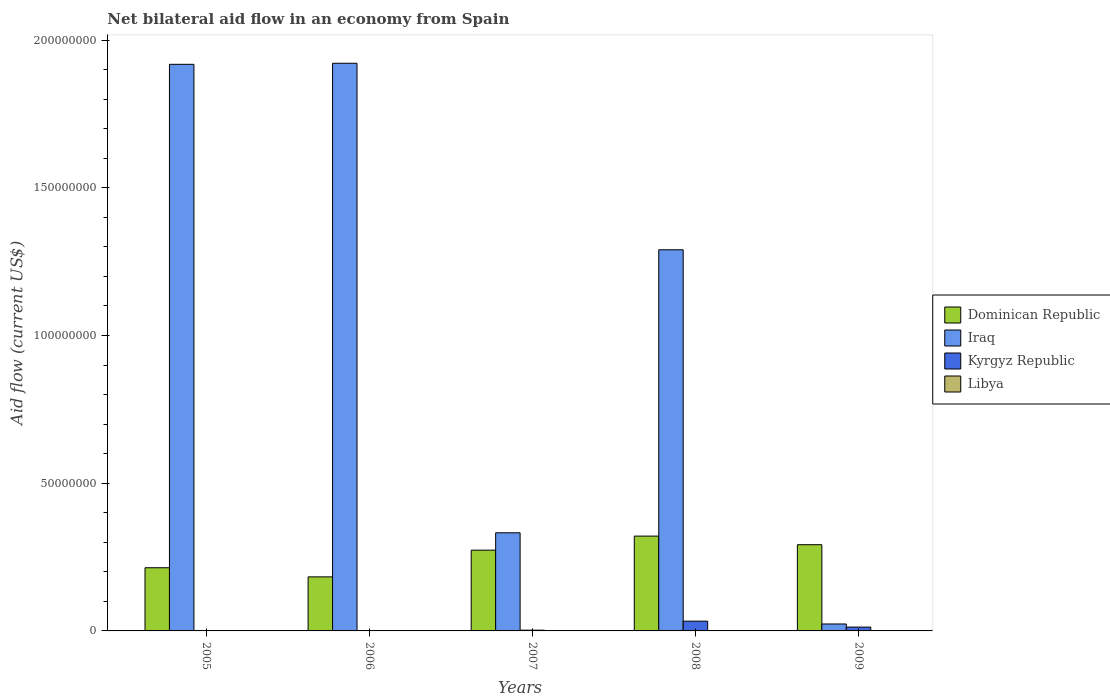Are the number of bars per tick equal to the number of legend labels?
Make the answer very short. Yes. Are the number of bars on each tick of the X-axis equal?
Provide a succinct answer. Yes. How many bars are there on the 2nd tick from the left?
Offer a terse response. 4. Across all years, what is the maximum net bilateral aid flow in Kyrgyz Republic?
Provide a short and direct response. 3.31e+06. Across all years, what is the minimum net bilateral aid flow in Dominican Republic?
Keep it short and to the point. 1.83e+07. In which year was the net bilateral aid flow in Dominican Republic maximum?
Your answer should be very brief. 2008. What is the total net bilateral aid flow in Libya in the graph?
Offer a terse response. 3.10e+05. What is the difference between the net bilateral aid flow in Iraq in 2007 and that in 2008?
Give a very brief answer. -9.58e+07. What is the difference between the net bilateral aid flow in Dominican Republic in 2007 and the net bilateral aid flow in Libya in 2006?
Ensure brevity in your answer.  2.73e+07. What is the average net bilateral aid flow in Kyrgyz Republic per year?
Your answer should be compact. 9.94e+05. In the year 2008, what is the difference between the net bilateral aid flow in Libya and net bilateral aid flow in Dominican Republic?
Ensure brevity in your answer.  -3.21e+07. In how many years, is the net bilateral aid flow in Libya greater than 100000000 US$?
Offer a very short reply. 0. What is the ratio of the net bilateral aid flow in Kyrgyz Republic in 2005 to that in 2008?
Your response must be concise. 0.02. Is the net bilateral aid flow in Kyrgyz Republic in 2008 less than that in 2009?
Give a very brief answer. No. Is the difference between the net bilateral aid flow in Libya in 2008 and 2009 greater than the difference between the net bilateral aid flow in Dominican Republic in 2008 and 2009?
Your response must be concise. No. What is the difference between the highest and the second highest net bilateral aid flow in Kyrgyz Republic?
Provide a succinct answer. 2.01e+06. What is the difference between the highest and the lowest net bilateral aid flow in Iraq?
Your answer should be very brief. 1.90e+08. In how many years, is the net bilateral aid flow in Dominican Republic greater than the average net bilateral aid flow in Dominican Republic taken over all years?
Offer a terse response. 3. What does the 4th bar from the left in 2008 represents?
Keep it short and to the point. Libya. What does the 1st bar from the right in 2008 represents?
Give a very brief answer. Libya. Is it the case that in every year, the sum of the net bilateral aid flow in Dominican Republic and net bilateral aid flow in Iraq is greater than the net bilateral aid flow in Kyrgyz Republic?
Provide a short and direct response. Yes. Are all the bars in the graph horizontal?
Offer a terse response. No. How many years are there in the graph?
Provide a succinct answer. 5. What is the difference between two consecutive major ticks on the Y-axis?
Provide a short and direct response. 5.00e+07. Are the values on the major ticks of Y-axis written in scientific E-notation?
Offer a terse response. No. Does the graph contain any zero values?
Provide a short and direct response. No. Where does the legend appear in the graph?
Provide a short and direct response. Center right. How many legend labels are there?
Ensure brevity in your answer.  4. What is the title of the graph?
Make the answer very short. Net bilateral aid flow in an economy from Spain. What is the label or title of the X-axis?
Provide a succinct answer. Years. What is the Aid flow (current US$) of Dominican Republic in 2005?
Make the answer very short. 2.14e+07. What is the Aid flow (current US$) of Iraq in 2005?
Your response must be concise. 1.92e+08. What is the Aid flow (current US$) of Kyrgyz Republic in 2005?
Offer a very short reply. 6.00e+04. What is the Aid flow (current US$) of Dominican Republic in 2006?
Give a very brief answer. 1.83e+07. What is the Aid flow (current US$) in Iraq in 2006?
Offer a very short reply. 1.92e+08. What is the Aid flow (current US$) in Kyrgyz Republic in 2006?
Your answer should be compact. 5.00e+04. What is the Aid flow (current US$) in Libya in 2006?
Offer a terse response. 4.00e+04. What is the Aid flow (current US$) of Dominican Republic in 2007?
Your response must be concise. 2.73e+07. What is the Aid flow (current US$) of Iraq in 2007?
Your answer should be very brief. 3.32e+07. What is the Aid flow (current US$) in Kyrgyz Republic in 2007?
Give a very brief answer. 2.50e+05. What is the Aid flow (current US$) of Dominican Republic in 2008?
Offer a terse response. 3.21e+07. What is the Aid flow (current US$) in Iraq in 2008?
Keep it short and to the point. 1.29e+08. What is the Aid flow (current US$) in Kyrgyz Republic in 2008?
Provide a succinct answer. 3.31e+06. What is the Aid flow (current US$) of Dominican Republic in 2009?
Keep it short and to the point. 2.92e+07. What is the Aid flow (current US$) in Iraq in 2009?
Give a very brief answer. 2.35e+06. What is the Aid flow (current US$) of Kyrgyz Republic in 2009?
Offer a very short reply. 1.30e+06. Across all years, what is the maximum Aid flow (current US$) of Dominican Republic?
Offer a very short reply. 3.21e+07. Across all years, what is the maximum Aid flow (current US$) in Iraq?
Give a very brief answer. 1.92e+08. Across all years, what is the maximum Aid flow (current US$) of Kyrgyz Republic?
Offer a terse response. 3.31e+06. Across all years, what is the maximum Aid flow (current US$) of Libya?
Keep it short and to the point. 1.20e+05. Across all years, what is the minimum Aid flow (current US$) of Dominican Republic?
Offer a terse response. 1.83e+07. Across all years, what is the minimum Aid flow (current US$) in Iraq?
Keep it short and to the point. 2.35e+06. Across all years, what is the minimum Aid flow (current US$) in Kyrgyz Republic?
Ensure brevity in your answer.  5.00e+04. Across all years, what is the minimum Aid flow (current US$) of Libya?
Your answer should be very brief. 10000. What is the total Aid flow (current US$) in Dominican Republic in the graph?
Provide a succinct answer. 1.28e+08. What is the total Aid flow (current US$) in Iraq in the graph?
Make the answer very short. 5.49e+08. What is the total Aid flow (current US$) of Kyrgyz Republic in the graph?
Provide a short and direct response. 4.97e+06. What is the difference between the Aid flow (current US$) in Dominican Republic in 2005 and that in 2006?
Your answer should be very brief. 3.09e+06. What is the difference between the Aid flow (current US$) of Iraq in 2005 and that in 2006?
Keep it short and to the point. -3.60e+05. What is the difference between the Aid flow (current US$) in Kyrgyz Republic in 2005 and that in 2006?
Provide a short and direct response. 10000. What is the difference between the Aid flow (current US$) in Dominican Republic in 2005 and that in 2007?
Offer a terse response. -5.95e+06. What is the difference between the Aid flow (current US$) of Iraq in 2005 and that in 2007?
Provide a succinct answer. 1.59e+08. What is the difference between the Aid flow (current US$) in Dominican Republic in 2005 and that in 2008?
Your answer should be very brief. -1.07e+07. What is the difference between the Aid flow (current US$) in Iraq in 2005 and that in 2008?
Provide a short and direct response. 6.28e+07. What is the difference between the Aid flow (current US$) in Kyrgyz Republic in 2005 and that in 2008?
Offer a very short reply. -3.25e+06. What is the difference between the Aid flow (current US$) of Libya in 2005 and that in 2008?
Give a very brief answer. 1.10e+05. What is the difference between the Aid flow (current US$) of Dominican Republic in 2005 and that in 2009?
Offer a terse response. -7.80e+06. What is the difference between the Aid flow (current US$) in Iraq in 2005 and that in 2009?
Your answer should be compact. 1.89e+08. What is the difference between the Aid flow (current US$) of Kyrgyz Republic in 2005 and that in 2009?
Make the answer very short. -1.24e+06. What is the difference between the Aid flow (current US$) in Dominican Republic in 2006 and that in 2007?
Offer a very short reply. -9.04e+06. What is the difference between the Aid flow (current US$) in Iraq in 2006 and that in 2007?
Ensure brevity in your answer.  1.59e+08. What is the difference between the Aid flow (current US$) in Libya in 2006 and that in 2007?
Offer a terse response. -6.00e+04. What is the difference between the Aid flow (current US$) of Dominican Republic in 2006 and that in 2008?
Your answer should be compact. -1.38e+07. What is the difference between the Aid flow (current US$) in Iraq in 2006 and that in 2008?
Provide a succinct answer. 6.31e+07. What is the difference between the Aid flow (current US$) in Kyrgyz Republic in 2006 and that in 2008?
Your answer should be very brief. -3.26e+06. What is the difference between the Aid flow (current US$) in Dominican Republic in 2006 and that in 2009?
Your response must be concise. -1.09e+07. What is the difference between the Aid flow (current US$) of Iraq in 2006 and that in 2009?
Provide a short and direct response. 1.90e+08. What is the difference between the Aid flow (current US$) in Kyrgyz Republic in 2006 and that in 2009?
Offer a very short reply. -1.25e+06. What is the difference between the Aid flow (current US$) of Dominican Republic in 2007 and that in 2008?
Make the answer very short. -4.76e+06. What is the difference between the Aid flow (current US$) of Iraq in 2007 and that in 2008?
Your answer should be very brief. -9.58e+07. What is the difference between the Aid flow (current US$) of Kyrgyz Republic in 2007 and that in 2008?
Offer a terse response. -3.06e+06. What is the difference between the Aid flow (current US$) of Dominican Republic in 2007 and that in 2009?
Keep it short and to the point. -1.85e+06. What is the difference between the Aid flow (current US$) of Iraq in 2007 and that in 2009?
Provide a short and direct response. 3.09e+07. What is the difference between the Aid flow (current US$) in Kyrgyz Republic in 2007 and that in 2009?
Provide a succinct answer. -1.05e+06. What is the difference between the Aid flow (current US$) in Libya in 2007 and that in 2009?
Keep it short and to the point. 6.00e+04. What is the difference between the Aid flow (current US$) in Dominican Republic in 2008 and that in 2009?
Give a very brief answer. 2.91e+06. What is the difference between the Aid flow (current US$) of Iraq in 2008 and that in 2009?
Your answer should be compact. 1.27e+08. What is the difference between the Aid flow (current US$) of Kyrgyz Republic in 2008 and that in 2009?
Your answer should be very brief. 2.01e+06. What is the difference between the Aid flow (current US$) in Dominican Republic in 2005 and the Aid flow (current US$) in Iraq in 2006?
Give a very brief answer. -1.71e+08. What is the difference between the Aid flow (current US$) of Dominican Republic in 2005 and the Aid flow (current US$) of Kyrgyz Republic in 2006?
Your answer should be very brief. 2.13e+07. What is the difference between the Aid flow (current US$) in Dominican Republic in 2005 and the Aid flow (current US$) in Libya in 2006?
Provide a succinct answer. 2.14e+07. What is the difference between the Aid flow (current US$) of Iraq in 2005 and the Aid flow (current US$) of Kyrgyz Republic in 2006?
Your response must be concise. 1.92e+08. What is the difference between the Aid flow (current US$) in Iraq in 2005 and the Aid flow (current US$) in Libya in 2006?
Give a very brief answer. 1.92e+08. What is the difference between the Aid flow (current US$) in Kyrgyz Republic in 2005 and the Aid flow (current US$) in Libya in 2006?
Ensure brevity in your answer.  2.00e+04. What is the difference between the Aid flow (current US$) of Dominican Republic in 2005 and the Aid flow (current US$) of Iraq in 2007?
Make the answer very short. -1.18e+07. What is the difference between the Aid flow (current US$) in Dominican Republic in 2005 and the Aid flow (current US$) in Kyrgyz Republic in 2007?
Make the answer very short. 2.11e+07. What is the difference between the Aid flow (current US$) in Dominican Republic in 2005 and the Aid flow (current US$) in Libya in 2007?
Keep it short and to the point. 2.13e+07. What is the difference between the Aid flow (current US$) of Iraq in 2005 and the Aid flow (current US$) of Kyrgyz Republic in 2007?
Your answer should be compact. 1.92e+08. What is the difference between the Aid flow (current US$) of Iraq in 2005 and the Aid flow (current US$) of Libya in 2007?
Keep it short and to the point. 1.92e+08. What is the difference between the Aid flow (current US$) in Dominican Republic in 2005 and the Aid flow (current US$) in Iraq in 2008?
Offer a very short reply. -1.08e+08. What is the difference between the Aid flow (current US$) in Dominican Republic in 2005 and the Aid flow (current US$) in Kyrgyz Republic in 2008?
Keep it short and to the point. 1.81e+07. What is the difference between the Aid flow (current US$) in Dominican Republic in 2005 and the Aid flow (current US$) in Libya in 2008?
Keep it short and to the point. 2.14e+07. What is the difference between the Aid flow (current US$) of Iraq in 2005 and the Aid flow (current US$) of Kyrgyz Republic in 2008?
Give a very brief answer. 1.88e+08. What is the difference between the Aid flow (current US$) in Iraq in 2005 and the Aid flow (current US$) in Libya in 2008?
Ensure brevity in your answer.  1.92e+08. What is the difference between the Aid flow (current US$) of Kyrgyz Republic in 2005 and the Aid flow (current US$) of Libya in 2008?
Give a very brief answer. 5.00e+04. What is the difference between the Aid flow (current US$) in Dominican Republic in 2005 and the Aid flow (current US$) in Iraq in 2009?
Your answer should be compact. 1.90e+07. What is the difference between the Aid flow (current US$) of Dominican Republic in 2005 and the Aid flow (current US$) of Kyrgyz Republic in 2009?
Make the answer very short. 2.01e+07. What is the difference between the Aid flow (current US$) in Dominican Republic in 2005 and the Aid flow (current US$) in Libya in 2009?
Your answer should be very brief. 2.14e+07. What is the difference between the Aid flow (current US$) of Iraq in 2005 and the Aid flow (current US$) of Kyrgyz Republic in 2009?
Provide a succinct answer. 1.91e+08. What is the difference between the Aid flow (current US$) of Iraq in 2005 and the Aid flow (current US$) of Libya in 2009?
Make the answer very short. 1.92e+08. What is the difference between the Aid flow (current US$) of Dominican Republic in 2006 and the Aid flow (current US$) of Iraq in 2007?
Make the answer very short. -1.49e+07. What is the difference between the Aid flow (current US$) in Dominican Republic in 2006 and the Aid flow (current US$) in Kyrgyz Republic in 2007?
Ensure brevity in your answer.  1.80e+07. What is the difference between the Aid flow (current US$) of Dominican Republic in 2006 and the Aid flow (current US$) of Libya in 2007?
Give a very brief answer. 1.82e+07. What is the difference between the Aid flow (current US$) in Iraq in 2006 and the Aid flow (current US$) in Kyrgyz Republic in 2007?
Give a very brief answer. 1.92e+08. What is the difference between the Aid flow (current US$) of Iraq in 2006 and the Aid flow (current US$) of Libya in 2007?
Provide a short and direct response. 1.92e+08. What is the difference between the Aid flow (current US$) in Dominican Republic in 2006 and the Aid flow (current US$) in Iraq in 2008?
Offer a very short reply. -1.11e+08. What is the difference between the Aid flow (current US$) of Dominican Republic in 2006 and the Aid flow (current US$) of Kyrgyz Republic in 2008?
Your response must be concise. 1.50e+07. What is the difference between the Aid flow (current US$) in Dominican Republic in 2006 and the Aid flow (current US$) in Libya in 2008?
Keep it short and to the point. 1.83e+07. What is the difference between the Aid flow (current US$) of Iraq in 2006 and the Aid flow (current US$) of Kyrgyz Republic in 2008?
Keep it short and to the point. 1.89e+08. What is the difference between the Aid flow (current US$) in Iraq in 2006 and the Aid flow (current US$) in Libya in 2008?
Make the answer very short. 1.92e+08. What is the difference between the Aid flow (current US$) in Dominican Republic in 2006 and the Aid flow (current US$) in Iraq in 2009?
Give a very brief answer. 1.60e+07. What is the difference between the Aid flow (current US$) of Dominican Republic in 2006 and the Aid flow (current US$) of Kyrgyz Republic in 2009?
Offer a very short reply. 1.70e+07. What is the difference between the Aid flow (current US$) of Dominican Republic in 2006 and the Aid flow (current US$) of Libya in 2009?
Ensure brevity in your answer.  1.83e+07. What is the difference between the Aid flow (current US$) in Iraq in 2006 and the Aid flow (current US$) in Kyrgyz Republic in 2009?
Your answer should be compact. 1.91e+08. What is the difference between the Aid flow (current US$) in Iraq in 2006 and the Aid flow (current US$) in Libya in 2009?
Your answer should be very brief. 1.92e+08. What is the difference between the Aid flow (current US$) of Kyrgyz Republic in 2006 and the Aid flow (current US$) of Libya in 2009?
Make the answer very short. 10000. What is the difference between the Aid flow (current US$) of Dominican Republic in 2007 and the Aid flow (current US$) of Iraq in 2008?
Offer a terse response. -1.02e+08. What is the difference between the Aid flow (current US$) in Dominican Republic in 2007 and the Aid flow (current US$) in Kyrgyz Republic in 2008?
Your response must be concise. 2.40e+07. What is the difference between the Aid flow (current US$) in Dominican Republic in 2007 and the Aid flow (current US$) in Libya in 2008?
Your response must be concise. 2.73e+07. What is the difference between the Aid flow (current US$) in Iraq in 2007 and the Aid flow (current US$) in Kyrgyz Republic in 2008?
Offer a very short reply. 2.99e+07. What is the difference between the Aid flow (current US$) in Iraq in 2007 and the Aid flow (current US$) in Libya in 2008?
Ensure brevity in your answer.  3.32e+07. What is the difference between the Aid flow (current US$) of Kyrgyz Republic in 2007 and the Aid flow (current US$) of Libya in 2008?
Keep it short and to the point. 2.40e+05. What is the difference between the Aid flow (current US$) of Dominican Republic in 2007 and the Aid flow (current US$) of Iraq in 2009?
Offer a very short reply. 2.50e+07. What is the difference between the Aid flow (current US$) of Dominican Republic in 2007 and the Aid flow (current US$) of Kyrgyz Republic in 2009?
Your answer should be compact. 2.60e+07. What is the difference between the Aid flow (current US$) in Dominican Republic in 2007 and the Aid flow (current US$) in Libya in 2009?
Offer a very short reply. 2.73e+07. What is the difference between the Aid flow (current US$) in Iraq in 2007 and the Aid flow (current US$) in Kyrgyz Republic in 2009?
Provide a short and direct response. 3.19e+07. What is the difference between the Aid flow (current US$) of Iraq in 2007 and the Aid flow (current US$) of Libya in 2009?
Your answer should be very brief. 3.32e+07. What is the difference between the Aid flow (current US$) of Kyrgyz Republic in 2007 and the Aid flow (current US$) of Libya in 2009?
Offer a very short reply. 2.10e+05. What is the difference between the Aid flow (current US$) of Dominican Republic in 2008 and the Aid flow (current US$) of Iraq in 2009?
Keep it short and to the point. 2.98e+07. What is the difference between the Aid flow (current US$) in Dominican Republic in 2008 and the Aid flow (current US$) in Kyrgyz Republic in 2009?
Your response must be concise. 3.08e+07. What is the difference between the Aid flow (current US$) in Dominican Republic in 2008 and the Aid flow (current US$) in Libya in 2009?
Your answer should be very brief. 3.21e+07. What is the difference between the Aid flow (current US$) of Iraq in 2008 and the Aid flow (current US$) of Kyrgyz Republic in 2009?
Your answer should be compact. 1.28e+08. What is the difference between the Aid flow (current US$) in Iraq in 2008 and the Aid flow (current US$) in Libya in 2009?
Your answer should be very brief. 1.29e+08. What is the difference between the Aid flow (current US$) in Kyrgyz Republic in 2008 and the Aid flow (current US$) in Libya in 2009?
Give a very brief answer. 3.27e+06. What is the average Aid flow (current US$) of Dominican Republic per year?
Your answer should be very brief. 2.57e+07. What is the average Aid flow (current US$) in Iraq per year?
Keep it short and to the point. 1.10e+08. What is the average Aid flow (current US$) in Kyrgyz Republic per year?
Offer a terse response. 9.94e+05. What is the average Aid flow (current US$) in Libya per year?
Offer a terse response. 6.20e+04. In the year 2005, what is the difference between the Aid flow (current US$) in Dominican Republic and Aid flow (current US$) in Iraq?
Your answer should be compact. -1.70e+08. In the year 2005, what is the difference between the Aid flow (current US$) in Dominican Republic and Aid flow (current US$) in Kyrgyz Republic?
Provide a short and direct response. 2.13e+07. In the year 2005, what is the difference between the Aid flow (current US$) of Dominican Republic and Aid flow (current US$) of Libya?
Your answer should be compact. 2.13e+07. In the year 2005, what is the difference between the Aid flow (current US$) in Iraq and Aid flow (current US$) in Kyrgyz Republic?
Offer a very short reply. 1.92e+08. In the year 2005, what is the difference between the Aid flow (current US$) of Iraq and Aid flow (current US$) of Libya?
Your response must be concise. 1.92e+08. In the year 2005, what is the difference between the Aid flow (current US$) of Kyrgyz Republic and Aid flow (current US$) of Libya?
Your response must be concise. -6.00e+04. In the year 2006, what is the difference between the Aid flow (current US$) of Dominican Republic and Aid flow (current US$) of Iraq?
Your answer should be very brief. -1.74e+08. In the year 2006, what is the difference between the Aid flow (current US$) in Dominican Republic and Aid flow (current US$) in Kyrgyz Republic?
Your response must be concise. 1.82e+07. In the year 2006, what is the difference between the Aid flow (current US$) in Dominican Republic and Aid flow (current US$) in Libya?
Your answer should be compact. 1.83e+07. In the year 2006, what is the difference between the Aid flow (current US$) of Iraq and Aid flow (current US$) of Kyrgyz Republic?
Offer a terse response. 1.92e+08. In the year 2006, what is the difference between the Aid flow (current US$) of Iraq and Aid flow (current US$) of Libya?
Your answer should be compact. 1.92e+08. In the year 2006, what is the difference between the Aid flow (current US$) of Kyrgyz Republic and Aid flow (current US$) of Libya?
Ensure brevity in your answer.  10000. In the year 2007, what is the difference between the Aid flow (current US$) of Dominican Republic and Aid flow (current US$) of Iraq?
Your answer should be compact. -5.88e+06. In the year 2007, what is the difference between the Aid flow (current US$) of Dominican Republic and Aid flow (current US$) of Kyrgyz Republic?
Your answer should be very brief. 2.71e+07. In the year 2007, what is the difference between the Aid flow (current US$) in Dominican Republic and Aid flow (current US$) in Libya?
Offer a very short reply. 2.72e+07. In the year 2007, what is the difference between the Aid flow (current US$) of Iraq and Aid flow (current US$) of Kyrgyz Republic?
Ensure brevity in your answer.  3.30e+07. In the year 2007, what is the difference between the Aid flow (current US$) of Iraq and Aid flow (current US$) of Libya?
Your answer should be compact. 3.31e+07. In the year 2007, what is the difference between the Aid flow (current US$) of Kyrgyz Republic and Aid flow (current US$) of Libya?
Your answer should be very brief. 1.50e+05. In the year 2008, what is the difference between the Aid flow (current US$) in Dominican Republic and Aid flow (current US$) in Iraq?
Offer a very short reply. -9.69e+07. In the year 2008, what is the difference between the Aid flow (current US$) of Dominican Republic and Aid flow (current US$) of Kyrgyz Republic?
Keep it short and to the point. 2.88e+07. In the year 2008, what is the difference between the Aid flow (current US$) of Dominican Republic and Aid flow (current US$) of Libya?
Provide a succinct answer. 3.21e+07. In the year 2008, what is the difference between the Aid flow (current US$) in Iraq and Aid flow (current US$) in Kyrgyz Republic?
Offer a very short reply. 1.26e+08. In the year 2008, what is the difference between the Aid flow (current US$) of Iraq and Aid flow (current US$) of Libya?
Provide a short and direct response. 1.29e+08. In the year 2008, what is the difference between the Aid flow (current US$) in Kyrgyz Republic and Aid flow (current US$) in Libya?
Keep it short and to the point. 3.30e+06. In the year 2009, what is the difference between the Aid flow (current US$) of Dominican Republic and Aid flow (current US$) of Iraq?
Your answer should be compact. 2.68e+07. In the year 2009, what is the difference between the Aid flow (current US$) in Dominican Republic and Aid flow (current US$) in Kyrgyz Republic?
Make the answer very short. 2.79e+07. In the year 2009, what is the difference between the Aid flow (current US$) of Dominican Republic and Aid flow (current US$) of Libya?
Ensure brevity in your answer.  2.92e+07. In the year 2009, what is the difference between the Aid flow (current US$) of Iraq and Aid flow (current US$) of Kyrgyz Republic?
Your response must be concise. 1.05e+06. In the year 2009, what is the difference between the Aid flow (current US$) in Iraq and Aid flow (current US$) in Libya?
Your answer should be very brief. 2.31e+06. In the year 2009, what is the difference between the Aid flow (current US$) in Kyrgyz Republic and Aid flow (current US$) in Libya?
Provide a succinct answer. 1.26e+06. What is the ratio of the Aid flow (current US$) in Dominican Republic in 2005 to that in 2006?
Offer a terse response. 1.17. What is the ratio of the Aid flow (current US$) in Iraq in 2005 to that in 2006?
Make the answer very short. 1. What is the ratio of the Aid flow (current US$) of Dominican Republic in 2005 to that in 2007?
Offer a very short reply. 0.78. What is the ratio of the Aid flow (current US$) in Iraq in 2005 to that in 2007?
Your answer should be very brief. 5.77. What is the ratio of the Aid flow (current US$) in Kyrgyz Republic in 2005 to that in 2007?
Your answer should be very brief. 0.24. What is the ratio of the Aid flow (current US$) in Dominican Republic in 2005 to that in 2008?
Offer a terse response. 0.67. What is the ratio of the Aid flow (current US$) of Iraq in 2005 to that in 2008?
Give a very brief answer. 1.49. What is the ratio of the Aid flow (current US$) in Kyrgyz Republic in 2005 to that in 2008?
Make the answer very short. 0.02. What is the ratio of the Aid flow (current US$) of Libya in 2005 to that in 2008?
Ensure brevity in your answer.  12. What is the ratio of the Aid flow (current US$) in Dominican Republic in 2005 to that in 2009?
Your response must be concise. 0.73. What is the ratio of the Aid flow (current US$) of Iraq in 2005 to that in 2009?
Your response must be concise. 81.62. What is the ratio of the Aid flow (current US$) of Kyrgyz Republic in 2005 to that in 2009?
Give a very brief answer. 0.05. What is the ratio of the Aid flow (current US$) in Dominican Republic in 2006 to that in 2007?
Provide a succinct answer. 0.67. What is the ratio of the Aid flow (current US$) in Iraq in 2006 to that in 2007?
Keep it short and to the point. 5.78. What is the ratio of the Aid flow (current US$) in Libya in 2006 to that in 2007?
Keep it short and to the point. 0.4. What is the ratio of the Aid flow (current US$) in Dominican Republic in 2006 to that in 2008?
Give a very brief answer. 0.57. What is the ratio of the Aid flow (current US$) of Iraq in 2006 to that in 2008?
Your response must be concise. 1.49. What is the ratio of the Aid flow (current US$) of Kyrgyz Republic in 2006 to that in 2008?
Your answer should be compact. 0.02. What is the ratio of the Aid flow (current US$) in Dominican Republic in 2006 to that in 2009?
Your response must be concise. 0.63. What is the ratio of the Aid flow (current US$) in Iraq in 2006 to that in 2009?
Your response must be concise. 81.77. What is the ratio of the Aid flow (current US$) in Kyrgyz Republic in 2006 to that in 2009?
Keep it short and to the point. 0.04. What is the ratio of the Aid flow (current US$) in Dominican Republic in 2007 to that in 2008?
Ensure brevity in your answer.  0.85. What is the ratio of the Aid flow (current US$) of Iraq in 2007 to that in 2008?
Provide a succinct answer. 0.26. What is the ratio of the Aid flow (current US$) in Kyrgyz Republic in 2007 to that in 2008?
Offer a terse response. 0.08. What is the ratio of the Aid flow (current US$) in Dominican Republic in 2007 to that in 2009?
Keep it short and to the point. 0.94. What is the ratio of the Aid flow (current US$) of Iraq in 2007 to that in 2009?
Ensure brevity in your answer.  14.14. What is the ratio of the Aid flow (current US$) in Kyrgyz Republic in 2007 to that in 2009?
Give a very brief answer. 0.19. What is the ratio of the Aid flow (current US$) in Dominican Republic in 2008 to that in 2009?
Ensure brevity in your answer.  1.1. What is the ratio of the Aid flow (current US$) in Iraq in 2008 to that in 2009?
Provide a short and direct response. 54.91. What is the ratio of the Aid flow (current US$) of Kyrgyz Republic in 2008 to that in 2009?
Your response must be concise. 2.55. What is the ratio of the Aid flow (current US$) of Libya in 2008 to that in 2009?
Ensure brevity in your answer.  0.25. What is the difference between the highest and the second highest Aid flow (current US$) in Dominican Republic?
Ensure brevity in your answer.  2.91e+06. What is the difference between the highest and the second highest Aid flow (current US$) of Iraq?
Provide a short and direct response. 3.60e+05. What is the difference between the highest and the second highest Aid flow (current US$) of Kyrgyz Republic?
Offer a terse response. 2.01e+06. What is the difference between the highest and the second highest Aid flow (current US$) of Libya?
Provide a succinct answer. 2.00e+04. What is the difference between the highest and the lowest Aid flow (current US$) of Dominican Republic?
Your answer should be compact. 1.38e+07. What is the difference between the highest and the lowest Aid flow (current US$) of Iraq?
Keep it short and to the point. 1.90e+08. What is the difference between the highest and the lowest Aid flow (current US$) in Kyrgyz Republic?
Make the answer very short. 3.26e+06. What is the difference between the highest and the lowest Aid flow (current US$) of Libya?
Your answer should be compact. 1.10e+05. 